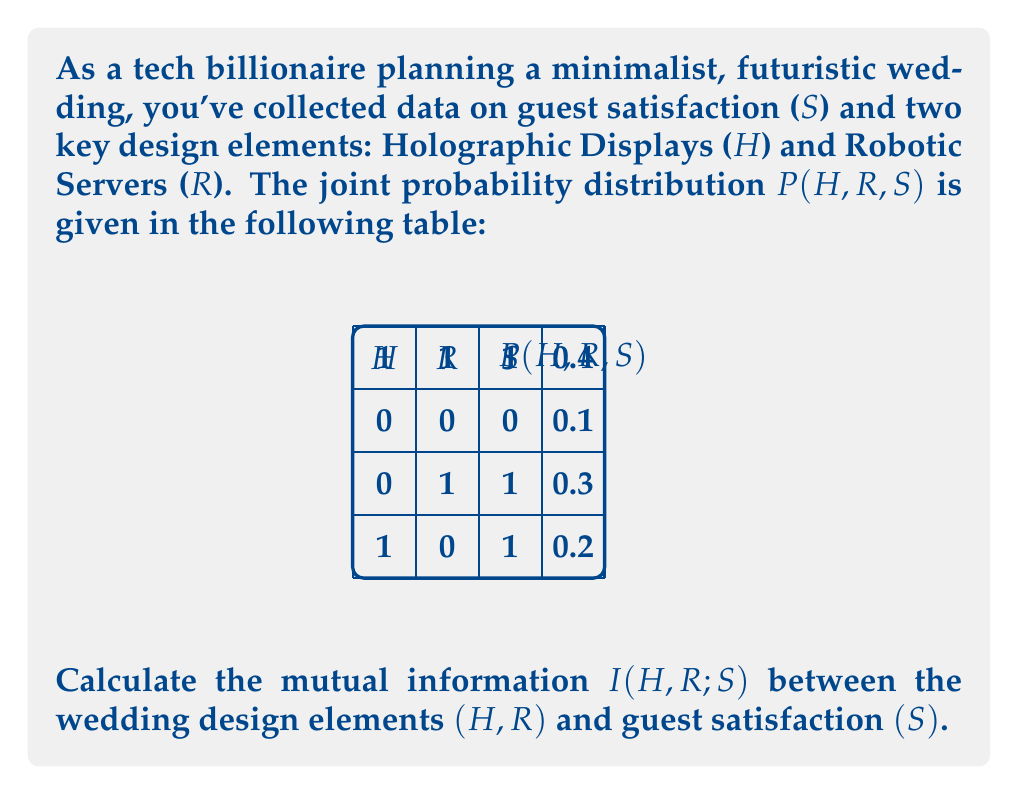Give your solution to this math problem. To calculate the mutual information I(H,R;S), we'll follow these steps:

1) First, recall the formula for mutual information:
   $$I(H,R;S) = H(S) - H(S|H,R)$$
   where H(S) is the entropy of S, and H(S|H,R) is the conditional entropy of S given H and R.

2) Calculate H(S):
   We need P(S=0) and P(S=1)
   P(S=0) = 0.1
   P(S=1) = 0.3 + 0.2 + 0.4 = 0.9
   $$H(S) = -0.1 \log_2(0.1) - 0.9 \log_2(0.9) = 0.469 \text{ bits}$$

3) Calculate H(S|H,R):
   $$H(S|H,R) = -\sum_{h,r,s} P(h,r,s) \log_2 P(s|h,r)$$
   
   P(S=0|H=0,R=0) = 1, P(S=1|H=0,R=1) = 1, P(S=1|H=1,R=0) = 1, P(S=1|H=1,R=1) = 1
   
   $$H(S|H,R) = -0.1 \log_2(1) - 0.3 \log_2(1) - 0.2 \log_2(1) - 0.4 \log_2(1) = 0$$

4) Calculate I(H,R;S):
   $$I(H,R;S) = H(S) - H(S|H,R) = 0.469 - 0 = 0.469 \text{ bits}$$
Answer: 0.469 bits 